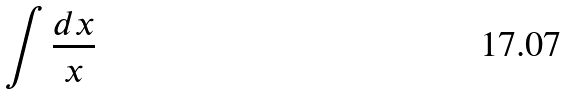Convert formula to latex. <formula><loc_0><loc_0><loc_500><loc_500>\int \frac { d x } { x }</formula> 